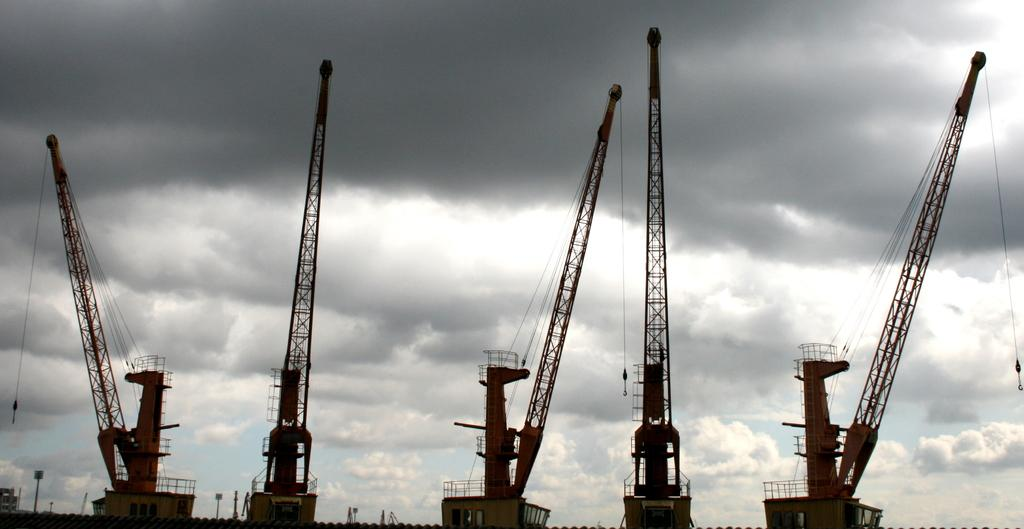What type of large birds are in the image? There are cranes in the image. How would you describe the sky in the image? The sky is blue and cloudy in the image. What reason do the cranes have for being in the image? The image does not provide any information about the reason for the cranes being present, so we cannot determine their reason from the image. 